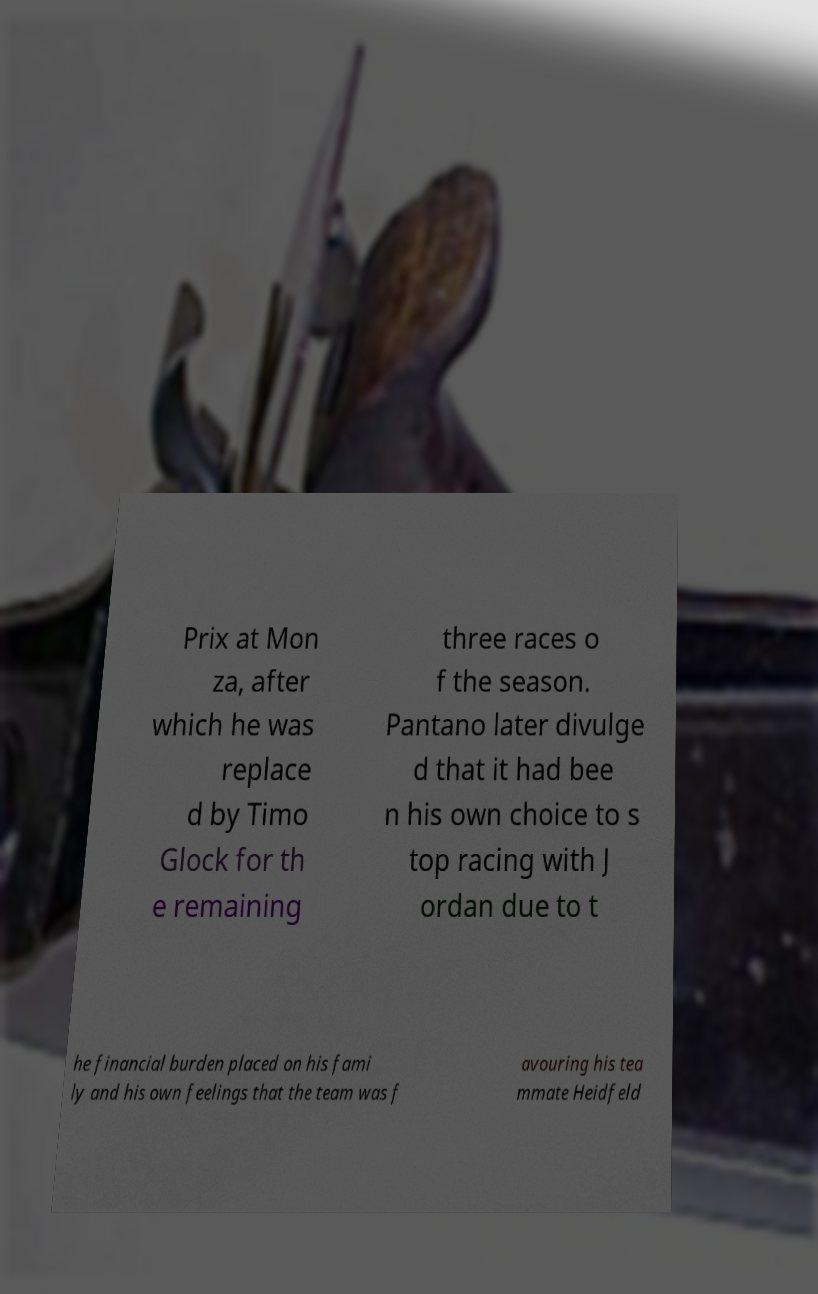Could you extract and type out the text from this image? Prix at Mon za, after which he was replace d by Timo Glock for th e remaining three races o f the season. Pantano later divulge d that it had bee n his own choice to s top racing with J ordan due to t he financial burden placed on his fami ly and his own feelings that the team was f avouring his tea mmate Heidfeld 